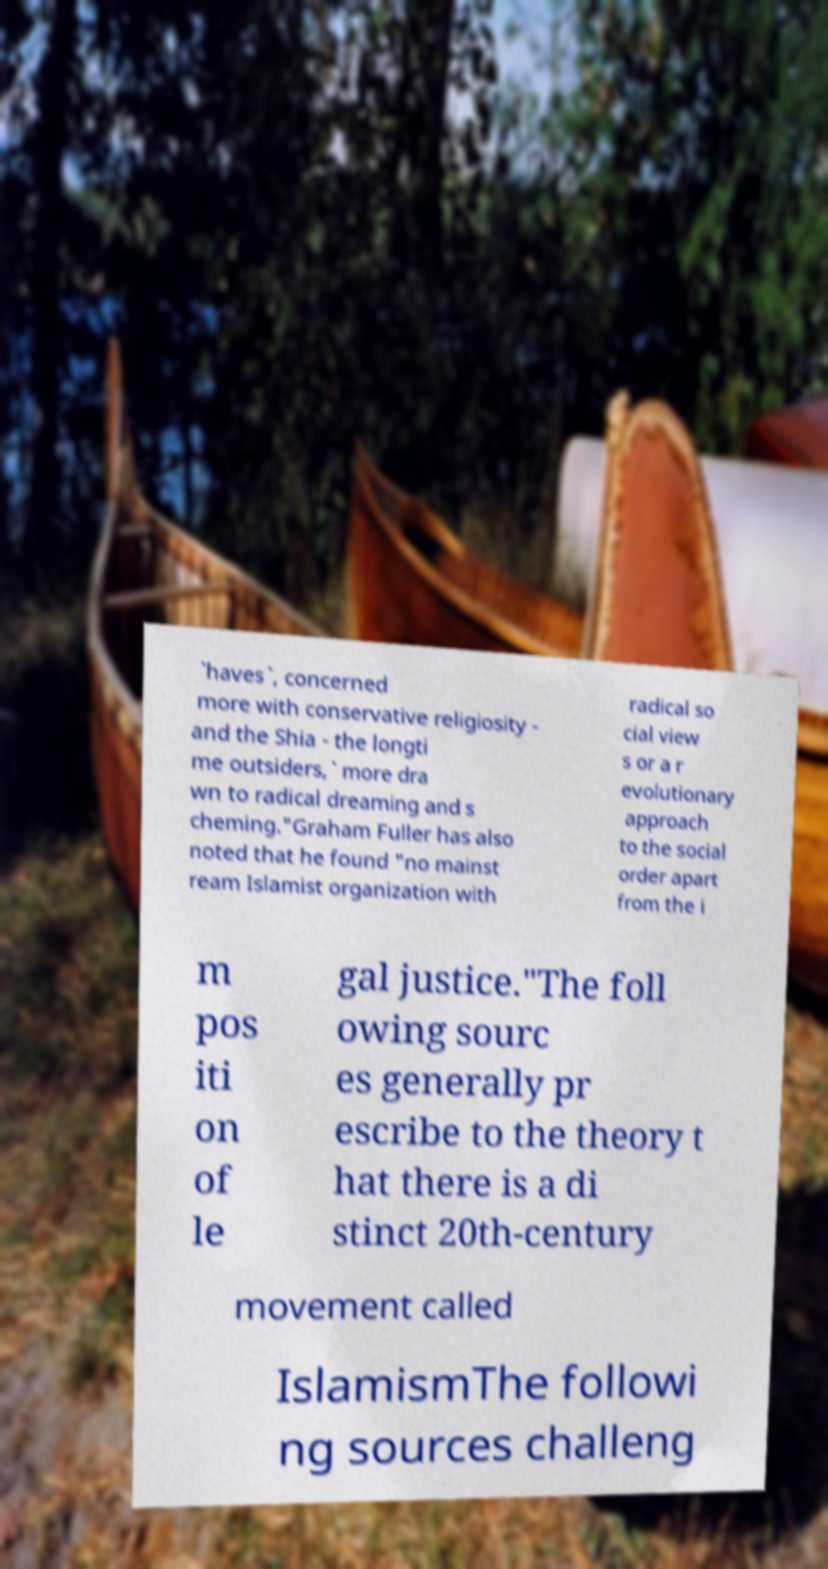Could you extract and type out the text from this image? `haves`, concerned more with conservative religiosity - and the Shia - the longti me outsiders,` more dra wn to radical dreaming and s cheming."Graham Fuller has also noted that he found "no mainst ream Islamist organization with radical so cial view s or a r evolutionary approach to the social order apart from the i m pos iti on of le gal justice."The foll owing sourc es generally pr escribe to the theory t hat there is a di stinct 20th-century movement called IslamismThe followi ng sources challeng 